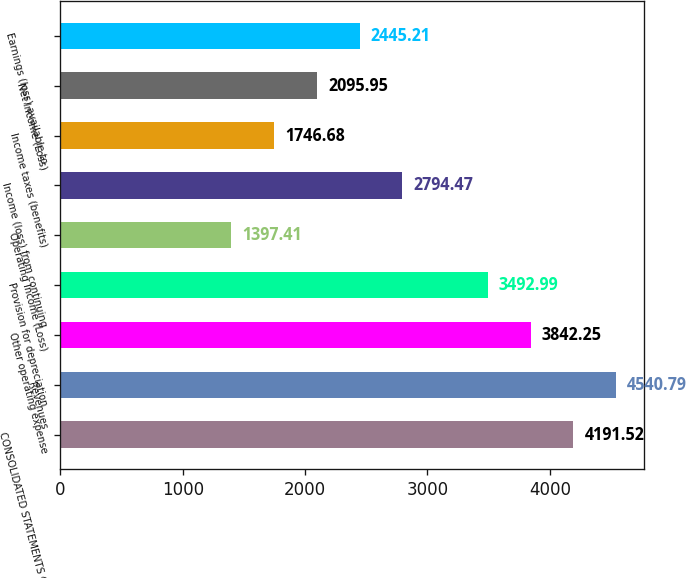Convert chart to OTSL. <chart><loc_0><loc_0><loc_500><loc_500><bar_chart><fcel>CONSOLIDATED STATEMENTS OF<fcel>Revenues<fcel>Other operating expense<fcel>Provision for depreciation<fcel>Operating Income (Loss)<fcel>Income (loss) from continuing<fcel>Income taxes (benefits)<fcel>Net Income (Loss)<fcel>Earnings (loss) available to<nl><fcel>4191.52<fcel>4540.79<fcel>3842.25<fcel>3492.99<fcel>1397.41<fcel>2794.47<fcel>1746.68<fcel>2095.95<fcel>2445.21<nl></chart> 